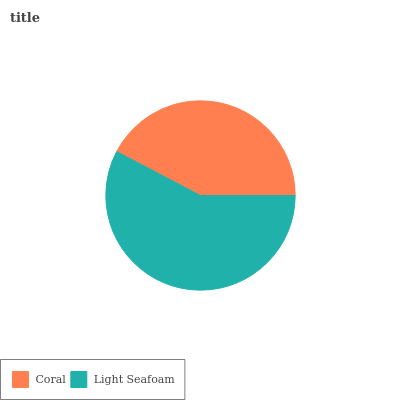Is Coral the minimum?
Answer yes or no. Yes. Is Light Seafoam the maximum?
Answer yes or no. Yes. Is Light Seafoam the minimum?
Answer yes or no. No. Is Light Seafoam greater than Coral?
Answer yes or no. Yes. Is Coral less than Light Seafoam?
Answer yes or no. Yes. Is Coral greater than Light Seafoam?
Answer yes or no. No. Is Light Seafoam less than Coral?
Answer yes or no. No. Is Light Seafoam the high median?
Answer yes or no. Yes. Is Coral the low median?
Answer yes or no. Yes. Is Coral the high median?
Answer yes or no. No. Is Light Seafoam the low median?
Answer yes or no. No. 